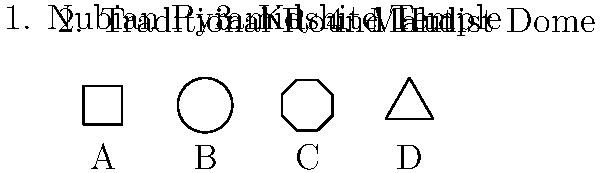Match the Sudanese architectural styles to their corresponding building outlines:

1. Nubian Pyramid
2. Traditional Round Hut
3. Kushite Temple
4. Mahdist Dome

A. Square
B. Circle
C. Octagon
D. Triangle To match Sudanese architectural styles to their building outlines, let's consider each style:

1. Nubian Pyramid: These ancient structures have a distinctive triangular shape when viewed from the side. The base is square, but the outline we see is triangular. This matches outline D.

2. Traditional Round Hut: As the name suggests, these dwellings have a circular base and a conical roof. The overall outline is circular, corresponding to outline B.

3. Kushite Temple: These temples often had complex layouts, but their general structure was typically rectangular or square. The outline that best represents this is A.

4. Mahdist Dome: Domes are typically built on a circular or octagonal base. In Sudanese architecture, octagonal bases were common for domes. This matches outline C.

Therefore, the correct matching is:
1-D, 2-B, 3-A, 4-C
Answer: 1-D, 2-B, 3-A, 4-C 